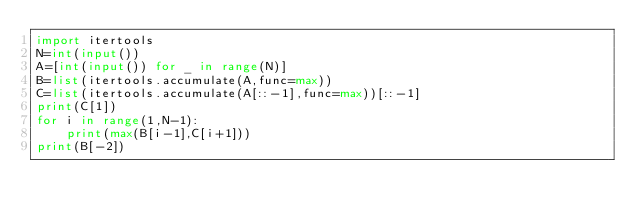<code> <loc_0><loc_0><loc_500><loc_500><_Python_>import itertools
N=int(input())
A=[int(input()) for _ in range(N)]
B=list(itertools.accumulate(A,func=max))
C=list(itertools.accumulate(A[::-1],func=max))[::-1]
print(C[1])
for i in range(1,N-1):
    print(max(B[i-1],C[i+1]))
print(B[-2])
</code> 